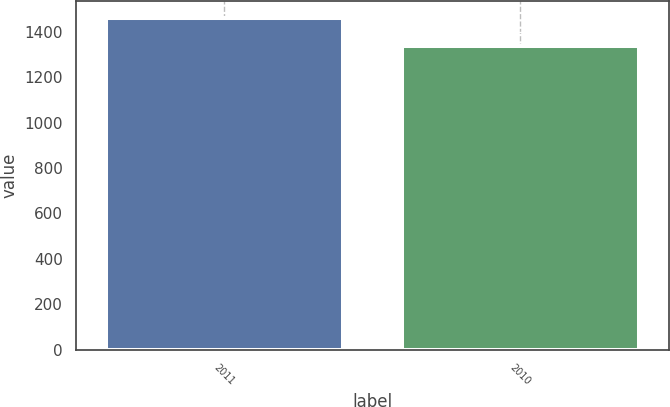<chart> <loc_0><loc_0><loc_500><loc_500><bar_chart><fcel>2011<fcel>2010<nl><fcel>1460<fcel>1335<nl></chart> 